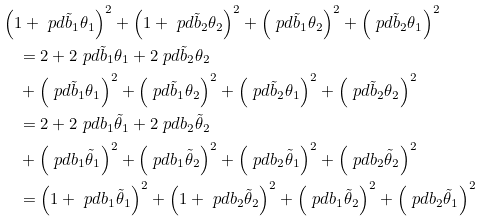Convert formula to latex. <formula><loc_0><loc_0><loc_500><loc_500>& \left ( 1 + \ p d { \tilde { b } _ { 1 } } { \theta _ { 1 } } \right ) ^ { 2 } + \left ( 1 + \ p d { \tilde { b } _ { 2 } } { \theta _ { 2 } } \right ) ^ { 2 } + \left ( \ p d { \tilde { b } _ { 1 } } { \theta _ { 2 } } \right ) ^ { 2 } + \left ( \ p d { \tilde { b } _ { 2 } } { \theta _ { 1 } } \right ) ^ { 2 } \\ & \quad = 2 + 2 \ p d { \tilde { b } _ { 1 } } { \theta _ { 1 } } + 2 \ p d { \tilde { b } _ { 2 } } { \theta _ { 2 } } \\ & \quad + \left ( \ p d { \tilde { b } _ { 1 } } { \theta _ { 1 } } \right ) ^ { 2 } + \left ( \ p d { \tilde { b } _ { 1 } } { \theta _ { 2 } } \right ) ^ { 2 } + \left ( \ p d { \tilde { b } _ { 2 } } { \theta _ { 1 } } \right ) ^ { 2 } + \left ( \ p d { \tilde { b } _ { 2 } } { \theta _ { 2 } } \right ) ^ { 2 } \\ & \quad = 2 + 2 \ p d { { b } _ { 1 } } { \tilde { \theta } _ { 1 } } + 2 \ p d { { b } _ { 2 } } { \tilde { \theta } _ { 2 } } \\ & \quad + \left ( \ p d { { b } _ { 1 } } { \tilde { \theta } _ { 1 } } \right ) ^ { 2 } + \left ( \ p d { { b } _ { 1 } } { \tilde { \theta } _ { 2 } } \right ) ^ { 2 } + \left ( \ p d { { b } _ { 2 } } { \tilde { \theta } _ { 1 } } \right ) ^ { 2 } + \left ( \ p d { { b } _ { 2 } } { \tilde { \theta } _ { 2 } } \right ) ^ { 2 } \\ & \quad = \left ( 1 + \ p d { { b } _ { 1 } } { \tilde { \theta } _ { 1 } } \right ) ^ { 2 } + \left ( 1 + \ p d { { b } _ { 2 } } { \tilde { \theta } _ { 2 } } \right ) ^ { 2 } + \left ( \ p d { { b } _ { 1 } } { \tilde { \theta } _ { 2 } } \right ) ^ { 2 } + \left ( \ p d { { b } _ { 2 } } { \tilde { \theta } _ { 1 } } \right ) ^ { 2 }</formula> 